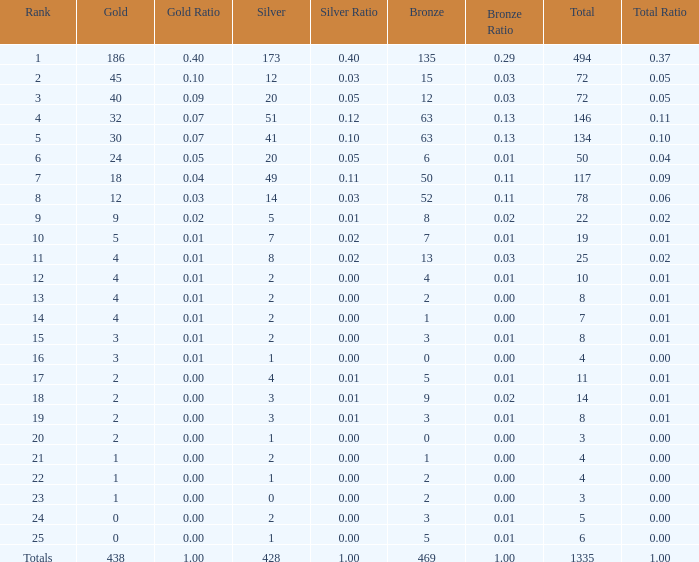What is the average number of gold medals when the total was 1335 medals, with more than 469 bronzes and more than 14 silvers? None. 